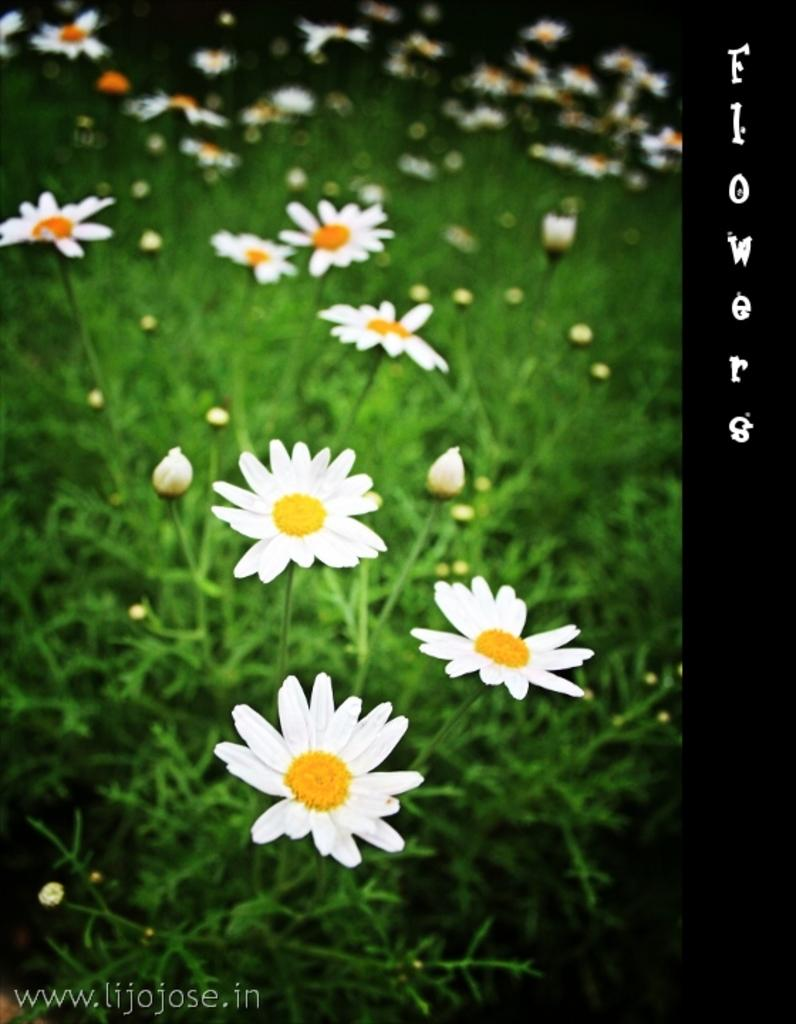What type of plants can be seen in the image? There are flowers in the image. Can you describe the stage of growth for some of the plants? There are buds in the image, which suggests they are in the early stages of growth. Is there any text or marking visible on the image? Yes, there is a watermark on the image. Can you tell me how many rivers are visible in the image? There are no rivers visible in the image; it features flowers and buds. What type of vegetable is shown growing in the image? There is no vegetable present in the image, only flowers and buds. 